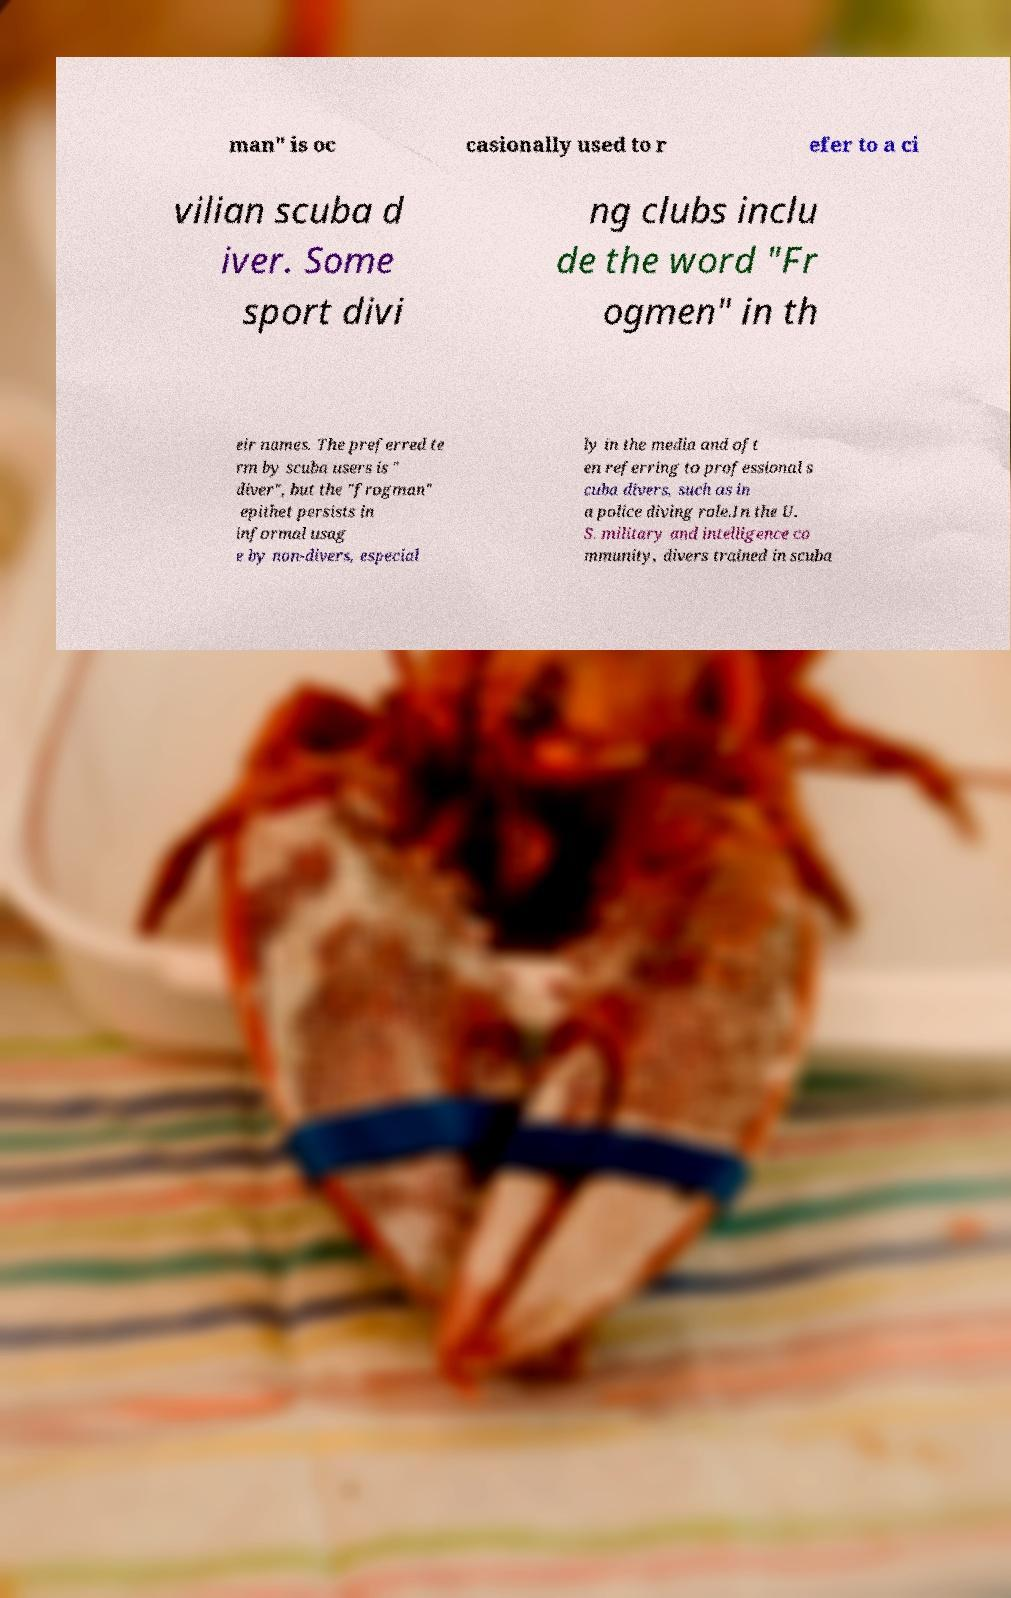Can you read and provide the text displayed in the image?This photo seems to have some interesting text. Can you extract and type it out for me? man" is oc casionally used to r efer to a ci vilian scuba d iver. Some sport divi ng clubs inclu de the word "Fr ogmen" in th eir names. The preferred te rm by scuba users is " diver", but the "frogman" epithet persists in informal usag e by non-divers, especial ly in the media and oft en referring to professional s cuba divers, such as in a police diving role.In the U. S. military and intelligence co mmunity, divers trained in scuba 